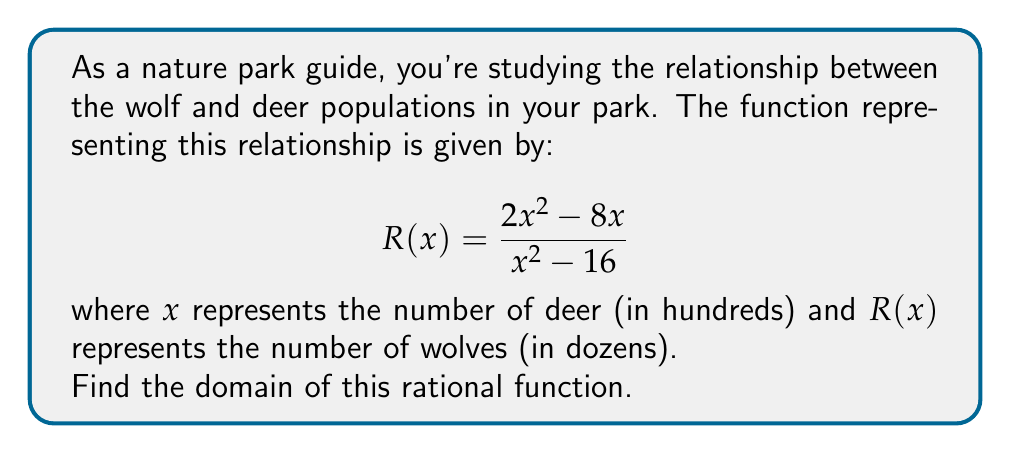Help me with this question. To find the domain of a rational function, we need to determine all real values of $x$ for which the function is defined. The function will be undefined when its denominator equals zero.

Step 1: Set the denominator equal to zero and solve for x.
$$x^2 - 16 = 0$$
$$(x - 4)(x + 4) = 0$$
$x = 4$ or $x = -4$

Step 2: Consider the biological context. Since $x$ represents the number of deer in hundreds, negative values don't make sense in this context. Therefore, we can discard the solution $x = -4$.

Step 3: Express the domain. The function is defined for all real numbers except when $x = 4$. In the context of our problem, this means the function is defined for all non-negative real numbers except 4.

Step 4: Interpret the result. Biologically, this means the relationship between wolves and deer is defined for any deer population except exactly 400 deer. At 400 deer, the function is undefined, which could indicate a critical point in the ecosystem where the relationship between predator and prey populations drastically changes or becomes unstable.
Answer: $\{x \in \mathbb{R} : x \geq 0 \text{ and } x \neq 4\}$ 